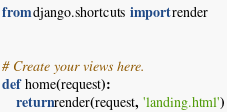<code> <loc_0><loc_0><loc_500><loc_500><_Python_>from django.shortcuts import render


# Create your views here.
def home(request):
    return render(request, 'landing.html')
</code> 